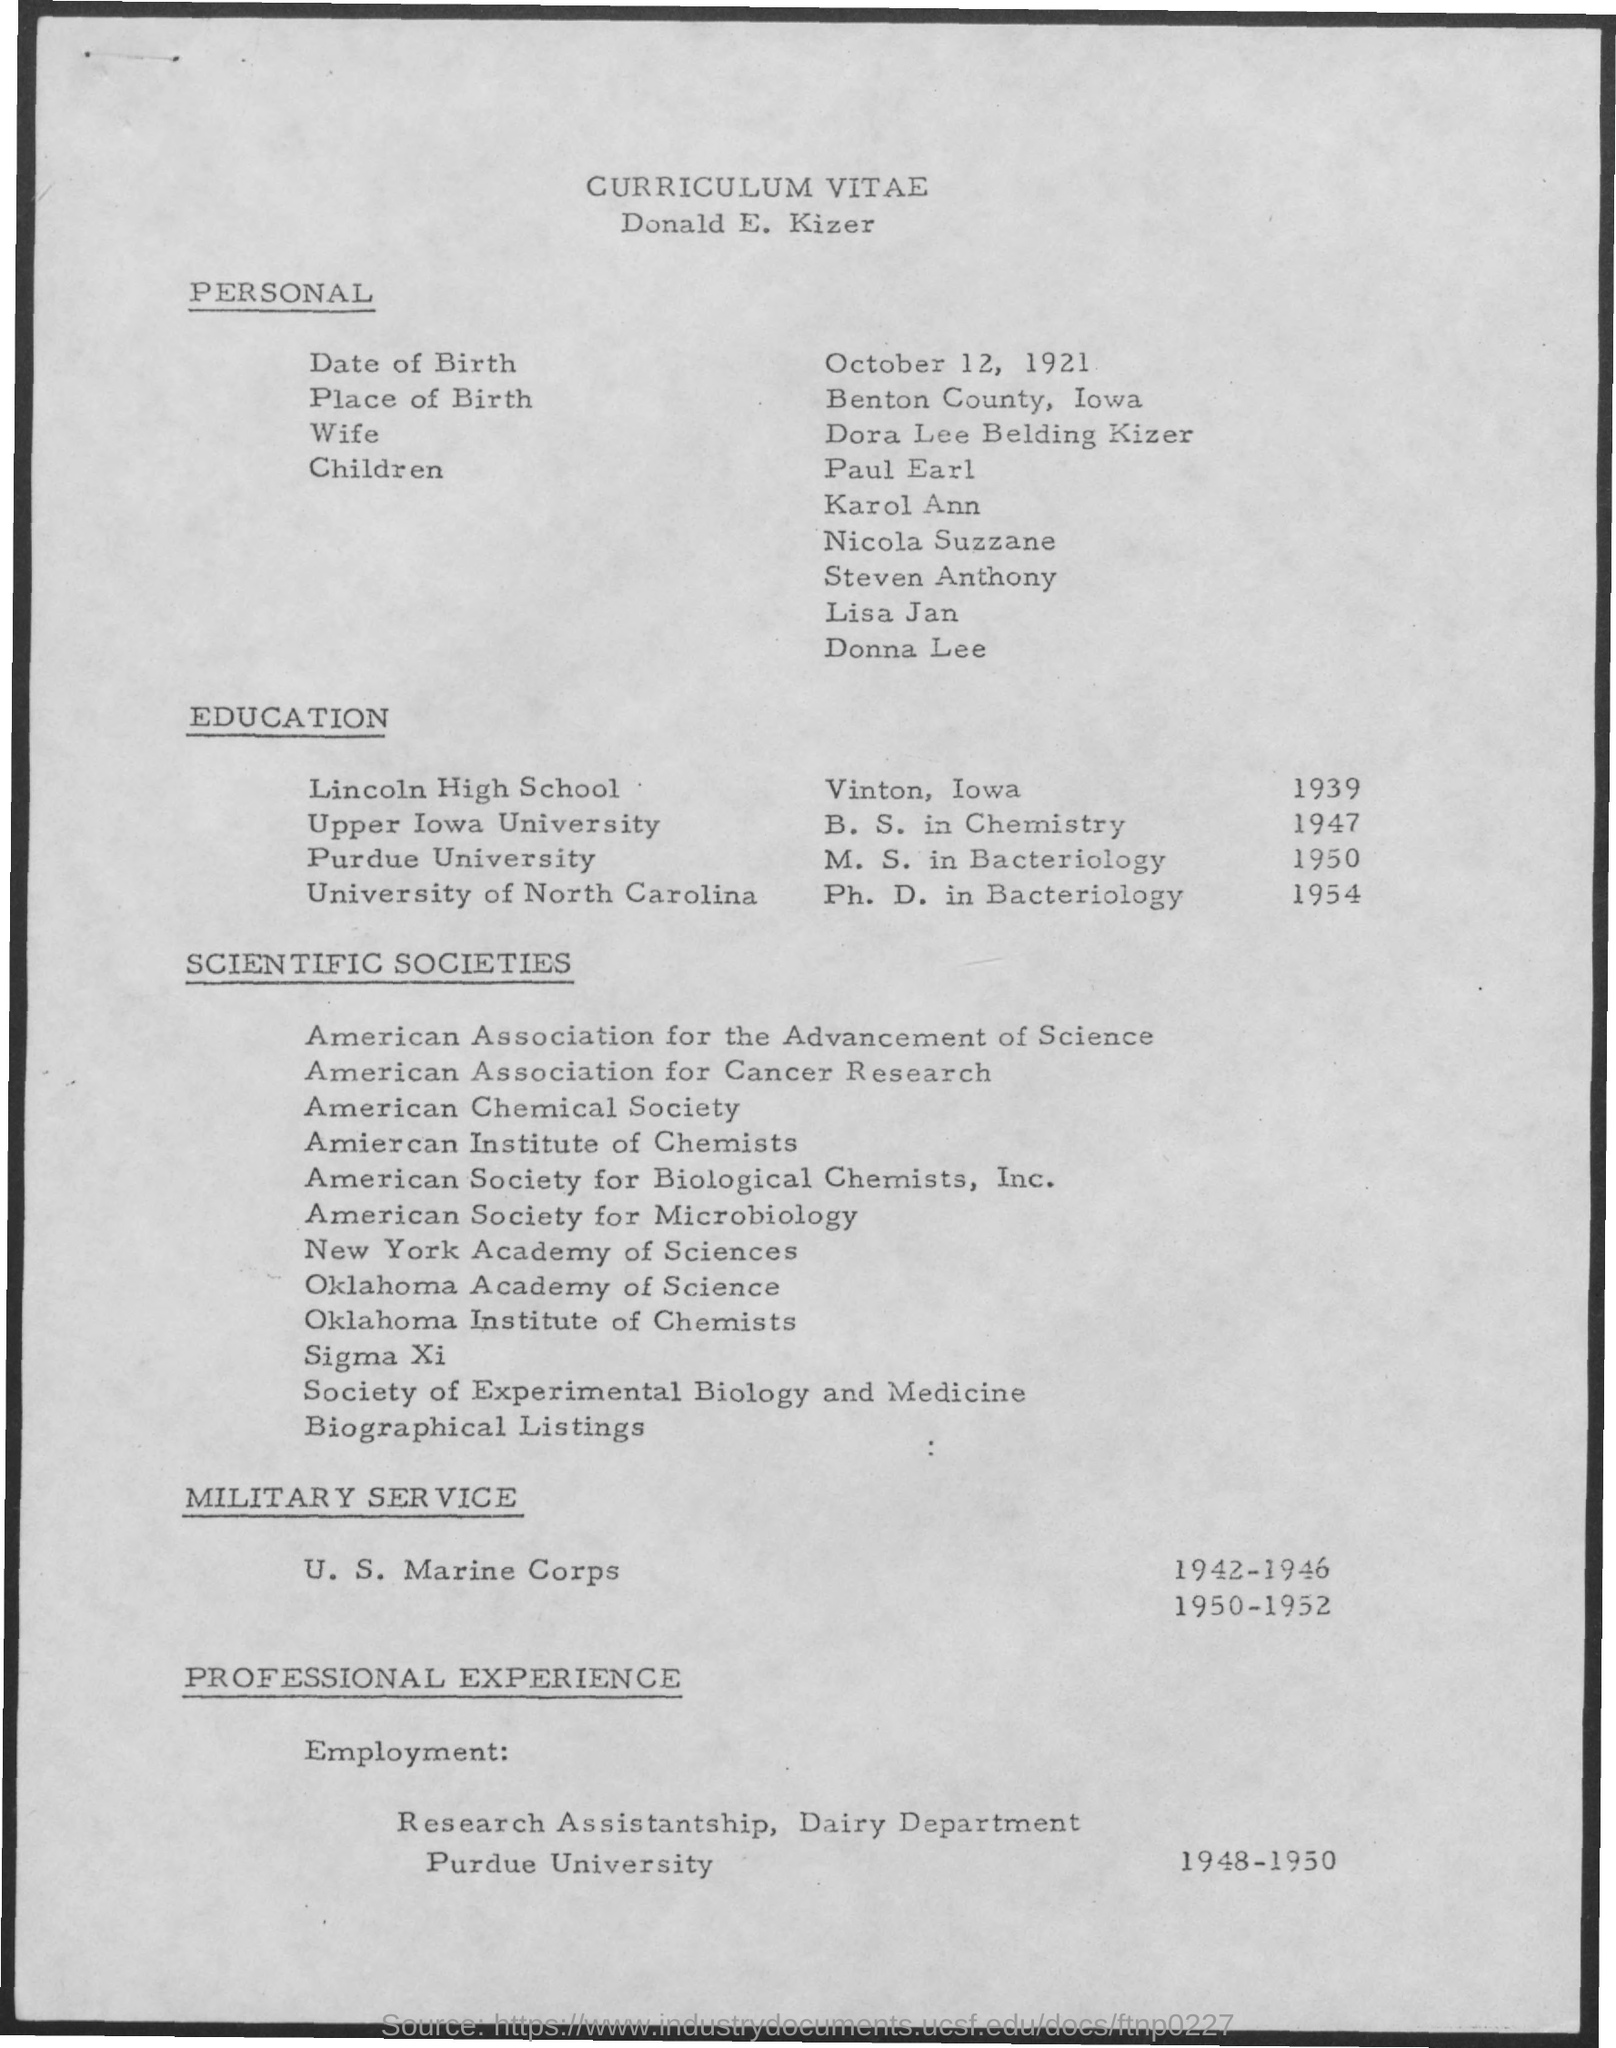What is the date of birth ?
Keep it short and to the point. October 12 , 1921. What is the place of birth ?
Offer a very short reply. Benton county , iowa. What is the name of his wife ?
Offer a terse response. Dora Lee Belding Kizer. In which year he has the professional experience of employment
Provide a succinct answer. 1948-1950. In which year he studied ph. d in bacteriology
Your answer should be very brief. 1954. In which year he studied b.s in chemistry ?
Your response must be concise. 1947. In which university he studied ph. d . in bacteriology
Provide a short and direct response. University of North Carolina. 